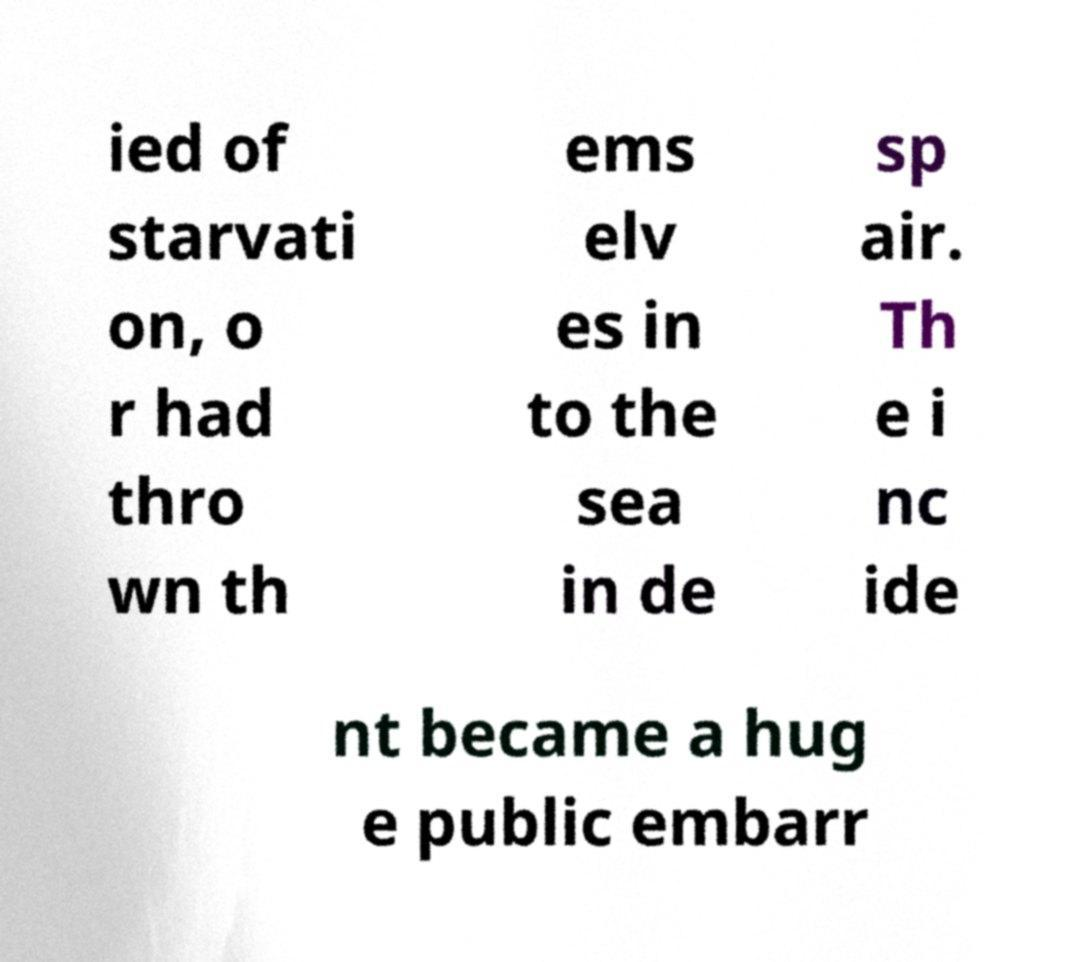What messages or text are displayed in this image? I need them in a readable, typed format. ied of starvati on, o r had thro wn th ems elv es in to the sea in de sp air. Th e i nc ide nt became a hug e public embarr 